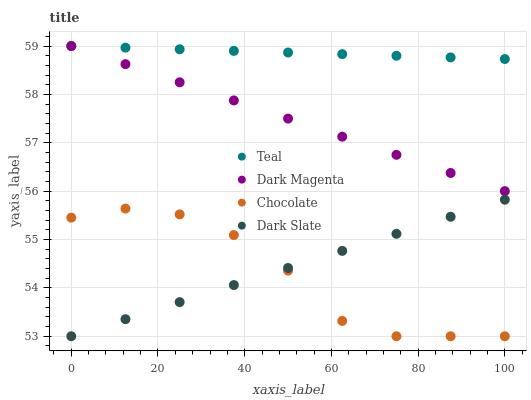Does Chocolate have the minimum area under the curve?
Answer yes or no. Yes. Does Teal have the maximum area under the curve?
Answer yes or no. Yes. Does Dark Magenta have the minimum area under the curve?
Answer yes or no. No. Does Dark Magenta have the maximum area under the curve?
Answer yes or no. No. Is Dark Magenta the smoothest?
Answer yes or no. Yes. Is Chocolate the roughest?
Answer yes or no. Yes. Is Teal the smoothest?
Answer yes or no. No. Is Teal the roughest?
Answer yes or no. No. Does Dark Slate have the lowest value?
Answer yes or no. Yes. Does Dark Magenta have the lowest value?
Answer yes or no. No. Does Teal have the highest value?
Answer yes or no. Yes. Does Chocolate have the highest value?
Answer yes or no. No. Is Chocolate less than Teal?
Answer yes or no. Yes. Is Dark Magenta greater than Dark Slate?
Answer yes or no. Yes. Does Dark Slate intersect Chocolate?
Answer yes or no. Yes. Is Dark Slate less than Chocolate?
Answer yes or no. No. Is Dark Slate greater than Chocolate?
Answer yes or no. No. Does Chocolate intersect Teal?
Answer yes or no. No. 